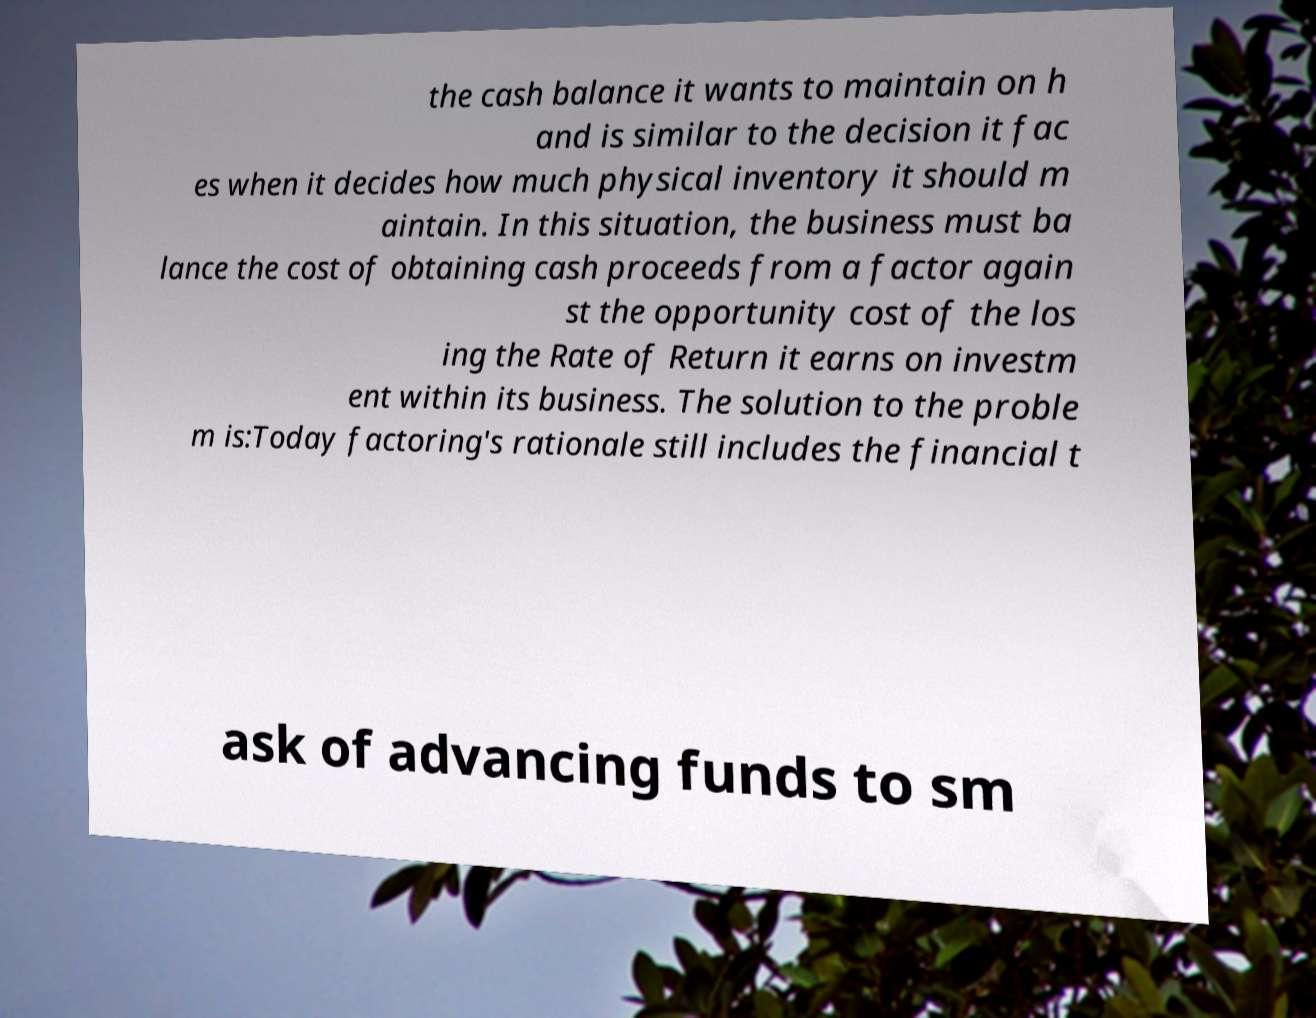Can you accurately transcribe the text from the provided image for me? the cash balance it wants to maintain on h and is similar to the decision it fac es when it decides how much physical inventory it should m aintain. In this situation, the business must ba lance the cost of obtaining cash proceeds from a factor again st the opportunity cost of the los ing the Rate of Return it earns on investm ent within its business. The solution to the proble m is:Today factoring's rationale still includes the financial t ask of advancing funds to sm 